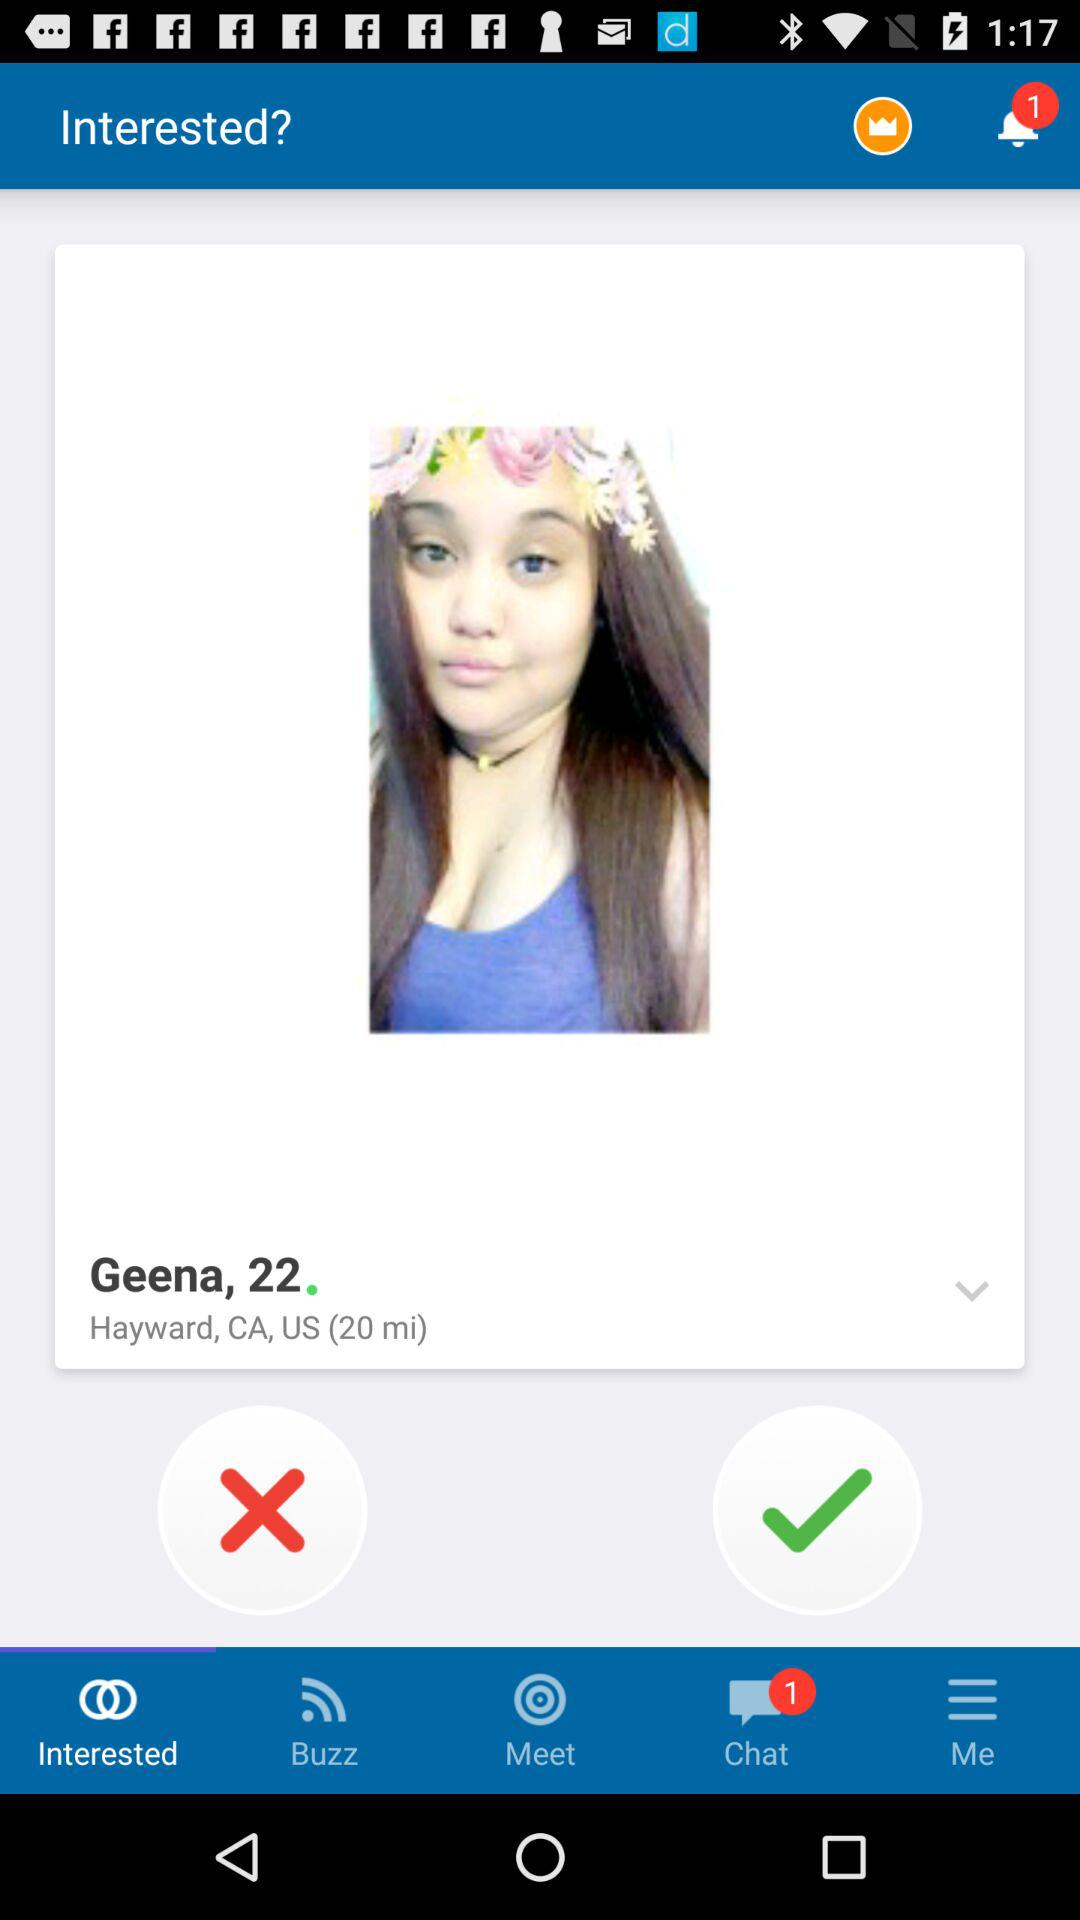What is the total number of unread notifications? There is only 1 unread notification. 